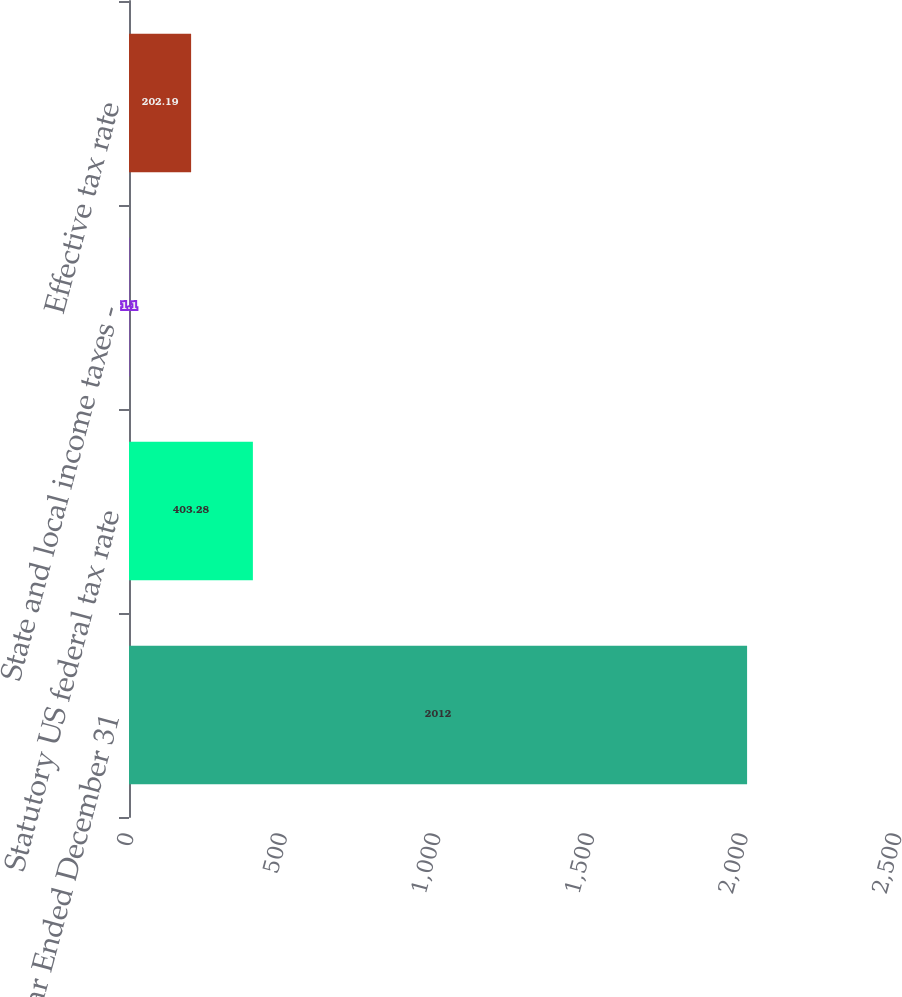Convert chart to OTSL. <chart><loc_0><loc_0><loc_500><loc_500><bar_chart><fcel>Year Ended December 31<fcel>Statutory US federal tax rate<fcel>State and local income taxes -<fcel>Effective tax rate<nl><fcel>2012<fcel>403.28<fcel>1.1<fcel>202.19<nl></chart> 